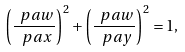Convert formula to latex. <formula><loc_0><loc_0><loc_500><loc_500>\left ( \frac { \ p a w } { \ p a x } \right ) ^ { 2 } + \left ( \frac { \ p a w } { \ p a y } \right ) ^ { 2 } = 1 ,</formula> 